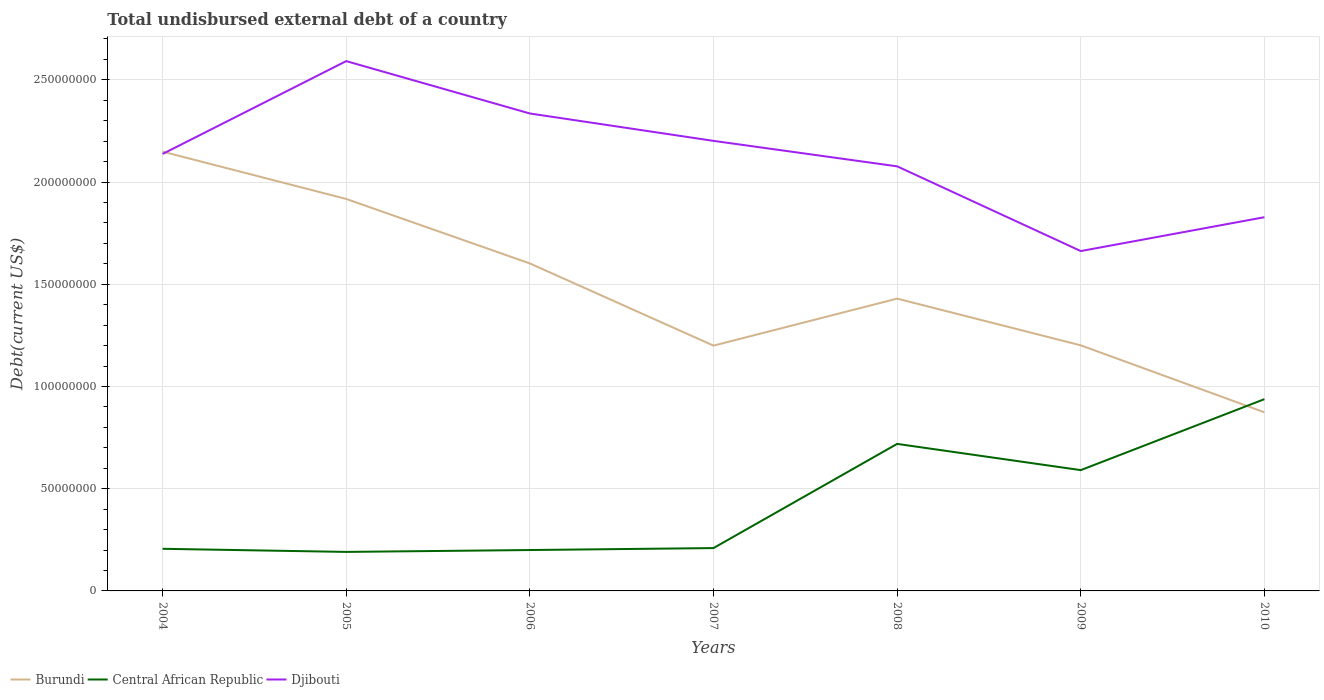How many different coloured lines are there?
Your response must be concise. 3. Is the number of lines equal to the number of legend labels?
Offer a terse response. Yes. Across all years, what is the maximum total undisbursed external debt in Djibouti?
Keep it short and to the point. 1.66e+08. In which year was the total undisbursed external debt in Djibouti maximum?
Give a very brief answer. 2009. What is the total total undisbursed external debt in Djibouti in the graph?
Provide a succinct answer. 2.56e+07. What is the difference between the highest and the second highest total undisbursed external debt in Burundi?
Your answer should be compact. 1.28e+08. What is the difference between the highest and the lowest total undisbursed external debt in Burundi?
Provide a succinct answer. 3. Is the total undisbursed external debt in Central African Republic strictly greater than the total undisbursed external debt in Burundi over the years?
Your answer should be very brief. No. What is the difference between two consecutive major ticks on the Y-axis?
Provide a succinct answer. 5.00e+07. Does the graph contain grids?
Provide a succinct answer. Yes. Where does the legend appear in the graph?
Provide a succinct answer. Bottom left. What is the title of the graph?
Give a very brief answer. Total undisbursed external debt of a country. Does "Philippines" appear as one of the legend labels in the graph?
Keep it short and to the point. No. What is the label or title of the Y-axis?
Give a very brief answer. Debt(current US$). What is the Debt(current US$) of Burundi in 2004?
Keep it short and to the point. 2.15e+08. What is the Debt(current US$) in Central African Republic in 2004?
Your answer should be very brief. 2.06e+07. What is the Debt(current US$) of Djibouti in 2004?
Provide a succinct answer. 2.14e+08. What is the Debt(current US$) in Burundi in 2005?
Your answer should be compact. 1.92e+08. What is the Debt(current US$) in Central African Republic in 2005?
Give a very brief answer. 1.91e+07. What is the Debt(current US$) of Djibouti in 2005?
Provide a succinct answer. 2.59e+08. What is the Debt(current US$) of Burundi in 2006?
Offer a terse response. 1.60e+08. What is the Debt(current US$) of Central African Republic in 2006?
Keep it short and to the point. 2.00e+07. What is the Debt(current US$) in Djibouti in 2006?
Keep it short and to the point. 2.34e+08. What is the Debt(current US$) of Burundi in 2007?
Your answer should be compact. 1.20e+08. What is the Debt(current US$) in Central African Republic in 2007?
Your answer should be compact. 2.10e+07. What is the Debt(current US$) in Djibouti in 2007?
Provide a short and direct response. 2.20e+08. What is the Debt(current US$) in Burundi in 2008?
Ensure brevity in your answer.  1.43e+08. What is the Debt(current US$) of Central African Republic in 2008?
Offer a very short reply. 7.19e+07. What is the Debt(current US$) in Djibouti in 2008?
Provide a succinct answer. 2.08e+08. What is the Debt(current US$) in Burundi in 2009?
Offer a terse response. 1.20e+08. What is the Debt(current US$) in Central African Republic in 2009?
Your response must be concise. 5.91e+07. What is the Debt(current US$) of Djibouti in 2009?
Make the answer very short. 1.66e+08. What is the Debt(current US$) in Burundi in 2010?
Give a very brief answer. 8.74e+07. What is the Debt(current US$) in Central African Republic in 2010?
Your answer should be compact. 9.38e+07. What is the Debt(current US$) of Djibouti in 2010?
Offer a terse response. 1.83e+08. Across all years, what is the maximum Debt(current US$) in Burundi?
Provide a short and direct response. 2.15e+08. Across all years, what is the maximum Debt(current US$) in Central African Republic?
Ensure brevity in your answer.  9.38e+07. Across all years, what is the maximum Debt(current US$) of Djibouti?
Provide a short and direct response. 2.59e+08. Across all years, what is the minimum Debt(current US$) of Burundi?
Ensure brevity in your answer.  8.74e+07. Across all years, what is the minimum Debt(current US$) in Central African Republic?
Provide a short and direct response. 1.91e+07. Across all years, what is the minimum Debt(current US$) of Djibouti?
Your answer should be compact. 1.66e+08. What is the total Debt(current US$) of Burundi in the graph?
Your answer should be very brief. 1.04e+09. What is the total Debt(current US$) of Central African Republic in the graph?
Ensure brevity in your answer.  3.05e+08. What is the total Debt(current US$) of Djibouti in the graph?
Offer a terse response. 1.48e+09. What is the difference between the Debt(current US$) in Burundi in 2004 and that in 2005?
Keep it short and to the point. 2.31e+07. What is the difference between the Debt(current US$) of Central African Republic in 2004 and that in 2005?
Ensure brevity in your answer.  1.52e+06. What is the difference between the Debt(current US$) in Djibouti in 2004 and that in 2005?
Your response must be concise. -4.54e+07. What is the difference between the Debt(current US$) in Burundi in 2004 and that in 2006?
Give a very brief answer. 5.47e+07. What is the difference between the Debt(current US$) of Central African Republic in 2004 and that in 2006?
Your response must be concise. 6.01e+05. What is the difference between the Debt(current US$) of Djibouti in 2004 and that in 2006?
Make the answer very short. -1.98e+07. What is the difference between the Debt(current US$) in Burundi in 2004 and that in 2007?
Your answer should be very brief. 9.49e+07. What is the difference between the Debt(current US$) in Central African Republic in 2004 and that in 2007?
Make the answer very short. -3.56e+05. What is the difference between the Debt(current US$) of Djibouti in 2004 and that in 2007?
Give a very brief answer. -6.40e+06. What is the difference between the Debt(current US$) of Burundi in 2004 and that in 2008?
Make the answer very short. 7.19e+07. What is the difference between the Debt(current US$) of Central African Republic in 2004 and that in 2008?
Give a very brief answer. -5.13e+07. What is the difference between the Debt(current US$) of Djibouti in 2004 and that in 2008?
Offer a very short reply. 6.05e+06. What is the difference between the Debt(current US$) of Burundi in 2004 and that in 2009?
Give a very brief answer. 9.48e+07. What is the difference between the Debt(current US$) of Central African Republic in 2004 and that in 2009?
Keep it short and to the point. -3.85e+07. What is the difference between the Debt(current US$) in Djibouti in 2004 and that in 2009?
Make the answer very short. 4.75e+07. What is the difference between the Debt(current US$) in Burundi in 2004 and that in 2010?
Provide a succinct answer. 1.28e+08. What is the difference between the Debt(current US$) in Central African Republic in 2004 and that in 2010?
Your answer should be very brief. -7.32e+07. What is the difference between the Debt(current US$) of Djibouti in 2004 and that in 2010?
Offer a terse response. 3.09e+07. What is the difference between the Debt(current US$) in Burundi in 2005 and that in 2006?
Offer a very short reply. 3.15e+07. What is the difference between the Debt(current US$) in Central African Republic in 2005 and that in 2006?
Your answer should be very brief. -9.19e+05. What is the difference between the Debt(current US$) in Djibouti in 2005 and that in 2006?
Make the answer very short. 2.56e+07. What is the difference between the Debt(current US$) in Burundi in 2005 and that in 2007?
Provide a succinct answer. 7.18e+07. What is the difference between the Debt(current US$) of Central African Republic in 2005 and that in 2007?
Keep it short and to the point. -1.88e+06. What is the difference between the Debt(current US$) of Djibouti in 2005 and that in 2007?
Give a very brief answer. 3.90e+07. What is the difference between the Debt(current US$) in Burundi in 2005 and that in 2008?
Your answer should be very brief. 4.88e+07. What is the difference between the Debt(current US$) of Central African Republic in 2005 and that in 2008?
Your answer should be very brief. -5.28e+07. What is the difference between the Debt(current US$) of Djibouti in 2005 and that in 2008?
Offer a very short reply. 5.15e+07. What is the difference between the Debt(current US$) in Burundi in 2005 and that in 2009?
Provide a short and direct response. 7.16e+07. What is the difference between the Debt(current US$) in Central African Republic in 2005 and that in 2009?
Provide a succinct answer. -4.00e+07. What is the difference between the Debt(current US$) in Djibouti in 2005 and that in 2009?
Provide a short and direct response. 9.29e+07. What is the difference between the Debt(current US$) of Burundi in 2005 and that in 2010?
Keep it short and to the point. 1.04e+08. What is the difference between the Debt(current US$) of Central African Republic in 2005 and that in 2010?
Your answer should be very brief. -7.47e+07. What is the difference between the Debt(current US$) in Djibouti in 2005 and that in 2010?
Provide a short and direct response. 7.64e+07. What is the difference between the Debt(current US$) of Burundi in 2006 and that in 2007?
Provide a short and direct response. 4.02e+07. What is the difference between the Debt(current US$) of Central African Republic in 2006 and that in 2007?
Your answer should be compact. -9.57e+05. What is the difference between the Debt(current US$) of Djibouti in 2006 and that in 2007?
Your response must be concise. 1.34e+07. What is the difference between the Debt(current US$) of Burundi in 2006 and that in 2008?
Offer a terse response. 1.72e+07. What is the difference between the Debt(current US$) of Central African Republic in 2006 and that in 2008?
Keep it short and to the point. -5.19e+07. What is the difference between the Debt(current US$) of Djibouti in 2006 and that in 2008?
Provide a short and direct response. 2.58e+07. What is the difference between the Debt(current US$) in Burundi in 2006 and that in 2009?
Your answer should be compact. 4.01e+07. What is the difference between the Debt(current US$) in Central African Republic in 2006 and that in 2009?
Your response must be concise. -3.91e+07. What is the difference between the Debt(current US$) in Djibouti in 2006 and that in 2009?
Offer a very short reply. 6.73e+07. What is the difference between the Debt(current US$) of Burundi in 2006 and that in 2010?
Offer a very short reply. 7.28e+07. What is the difference between the Debt(current US$) of Central African Republic in 2006 and that in 2010?
Your answer should be very brief. -7.38e+07. What is the difference between the Debt(current US$) in Djibouti in 2006 and that in 2010?
Your answer should be very brief. 5.07e+07. What is the difference between the Debt(current US$) of Burundi in 2007 and that in 2008?
Make the answer very short. -2.30e+07. What is the difference between the Debt(current US$) of Central African Republic in 2007 and that in 2008?
Ensure brevity in your answer.  -5.10e+07. What is the difference between the Debt(current US$) in Djibouti in 2007 and that in 2008?
Your response must be concise. 1.25e+07. What is the difference between the Debt(current US$) in Burundi in 2007 and that in 2009?
Make the answer very short. -1.48e+05. What is the difference between the Debt(current US$) of Central African Republic in 2007 and that in 2009?
Give a very brief answer. -3.81e+07. What is the difference between the Debt(current US$) of Djibouti in 2007 and that in 2009?
Give a very brief answer. 5.39e+07. What is the difference between the Debt(current US$) of Burundi in 2007 and that in 2010?
Your response must be concise. 3.26e+07. What is the difference between the Debt(current US$) in Central African Republic in 2007 and that in 2010?
Provide a succinct answer. -7.28e+07. What is the difference between the Debt(current US$) in Djibouti in 2007 and that in 2010?
Provide a succinct answer. 3.73e+07. What is the difference between the Debt(current US$) in Burundi in 2008 and that in 2009?
Offer a terse response. 2.28e+07. What is the difference between the Debt(current US$) in Central African Republic in 2008 and that in 2009?
Your answer should be compact. 1.28e+07. What is the difference between the Debt(current US$) of Djibouti in 2008 and that in 2009?
Your answer should be compact. 4.14e+07. What is the difference between the Debt(current US$) of Burundi in 2008 and that in 2010?
Offer a terse response. 5.56e+07. What is the difference between the Debt(current US$) of Central African Republic in 2008 and that in 2010?
Provide a short and direct response. -2.19e+07. What is the difference between the Debt(current US$) of Djibouti in 2008 and that in 2010?
Give a very brief answer. 2.49e+07. What is the difference between the Debt(current US$) in Burundi in 2009 and that in 2010?
Your response must be concise. 3.27e+07. What is the difference between the Debt(current US$) in Central African Republic in 2009 and that in 2010?
Ensure brevity in your answer.  -3.47e+07. What is the difference between the Debt(current US$) of Djibouti in 2009 and that in 2010?
Offer a terse response. -1.66e+07. What is the difference between the Debt(current US$) in Burundi in 2004 and the Debt(current US$) in Central African Republic in 2005?
Keep it short and to the point. 1.96e+08. What is the difference between the Debt(current US$) of Burundi in 2004 and the Debt(current US$) of Djibouti in 2005?
Your response must be concise. -4.43e+07. What is the difference between the Debt(current US$) in Central African Republic in 2004 and the Debt(current US$) in Djibouti in 2005?
Your answer should be very brief. -2.39e+08. What is the difference between the Debt(current US$) of Burundi in 2004 and the Debt(current US$) of Central African Republic in 2006?
Provide a succinct answer. 1.95e+08. What is the difference between the Debt(current US$) in Burundi in 2004 and the Debt(current US$) in Djibouti in 2006?
Your answer should be compact. -1.87e+07. What is the difference between the Debt(current US$) of Central African Republic in 2004 and the Debt(current US$) of Djibouti in 2006?
Provide a short and direct response. -2.13e+08. What is the difference between the Debt(current US$) of Burundi in 2004 and the Debt(current US$) of Central African Republic in 2007?
Your answer should be compact. 1.94e+08. What is the difference between the Debt(current US$) in Burundi in 2004 and the Debt(current US$) in Djibouti in 2007?
Provide a succinct answer. -5.26e+06. What is the difference between the Debt(current US$) of Central African Republic in 2004 and the Debt(current US$) of Djibouti in 2007?
Ensure brevity in your answer.  -2.00e+08. What is the difference between the Debt(current US$) of Burundi in 2004 and the Debt(current US$) of Central African Republic in 2008?
Offer a very short reply. 1.43e+08. What is the difference between the Debt(current US$) in Burundi in 2004 and the Debt(current US$) in Djibouti in 2008?
Offer a terse response. 7.19e+06. What is the difference between the Debt(current US$) of Central African Republic in 2004 and the Debt(current US$) of Djibouti in 2008?
Make the answer very short. -1.87e+08. What is the difference between the Debt(current US$) in Burundi in 2004 and the Debt(current US$) in Central African Republic in 2009?
Ensure brevity in your answer.  1.56e+08. What is the difference between the Debt(current US$) of Burundi in 2004 and the Debt(current US$) of Djibouti in 2009?
Give a very brief answer. 4.86e+07. What is the difference between the Debt(current US$) in Central African Republic in 2004 and the Debt(current US$) in Djibouti in 2009?
Offer a very short reply. -1.46e+08. What is the difference between the Debt(current US$) in Burundi in 2004 and the Debt(current US$) in Central African Republic in 2010?
Make the answer very short. 1.21e+08. What is the difference between the Debt(current US$) of Burundi in 2004 and the Debt(current US$) of Djibouti in 2010?
Give a very brief answer. 3.21e+07. What is the difference between the Debt(current US$) in Central African Republic in 2004 and the Debt(current US$) in Djibouti in 2010?
Ensure brevity in your answer.  -1.62e+08. What is the difference between the Debt(current US$) in Burundi in 2005 and the Debt(current US$) in Central African Republic in 2006?
Make the answer very short. 1.72e+08. What is the difference between the Debt(current US$) of Burundi in 2005 and the Debt(current US$) of Djibouti in 2006?
Give a very brief answer. -4.18e+07. What is the difference between the Debt(current US$) in Central African Republic in 2005 and the Debt(current US$) in Djibouti in 2006?
Provide a succinct answer. -2.14e+08. What is the difference between the Debt(current US$) in Burundi in 2005 and the Debt(current US$) in Central African Republic in 2007?
Keep it short and to the point. 1.71e+08. What is the difference between the Debt(current US$) of Burundi in 2005 and the Debt(current US$) of Djibouti in 2007?
Provide a short and direct response. -2.84e+07. What is the difference between the Debt(current US$) in Central African Republic in 2005 and the Debt(current US$) in Djibouti in 2007?
Provide a succinct answer. -2.01e+08. What is the difference between the Debt(current US$) of Burundi in 2005 and the Debt(current US$) of Central African Republic in 2008?
Offer a terse response. 1.20e+08. What is the difference between the Debt(current US$) in Burundi in 2005 and the Debt(current US$) in Djibouti in 2008?
Offer a terse response. -1.60e+07. What is the difference between the Debt(current US$) in Central African Republic in 2005 and the Debt(current US$) in Djibouti in 2008?
Provide a short and direct response. -1.89e+08. What is the difference between the Debt(current US$) in Burundi in 2005 and the Debt(current US$) in Central African Republic in 2009?
Provide a short and direct response. 1.33e+08. What is the difference between the Debt(current US$) of Burundi in 2005 and the Debt(current US$) of Djibouti in 2009?
Provide a succinct answer. 2.55e+07. What is the difference between the Debt(current US$) of Central African Republic in 2005 and the Debt(current US$) of Djibouti in 2009?
Provide a short and direct response. -1.47e+08. What is the difference between the Debt(current US$) of Burundi in 2005 and the Debt(current US$) of Central African Republic in 2010?
Provide a succinct answer. 9.79e+07. What is the difference between the Debt(current US$) in Burundi in 2005 and the Debt(current US$) in Djibouti in 2010?
Give a very brief answer. 8.93e+06. What is the difference between the Debt(current US$) of Central African Republic in 2005 and the Debt(current US$) of Djibouti in 2010?
Give a very brief answer. -1.64e+08. What is the difference between the Debt(current US$) in Burundi in 2006 and the Debt(current US$) in Central African Republic in 2007?
Your response must be concise. 1.39e+08. What is the difference between the Debt(current US$) of Burundi in 2006 and the Debt(current US$) of Djibouti in 2007?
Give a very brief answer. -6.00e+07. What is the difference between the Debt(current US$) in Central African Republic in 2006 and the Debt(current US$) in Djibouti in 2007?
Ensure brevity in your answer.  -2.00e+08. What is the difference between the Debt(current US$) of Burundi in 2006 and the Debt(current US$) of Central African Republic in 2008?
Make the answer very short. 8.83e+07. What is the difference between the Debt(current US$) of Burundi in 2006 and the Debt(current US$) of Djibouti in 2008?
Offer a terse response. -4.75e+07. What is the difference between the Debt(current US$) of Central African Republic in 2006 and the Debt(current US$) of Djibouti in 2008?
Give a very brief answer. -1.88e+08. What is the difference between the Debt(current US$) in Burundi in 2006 and the Debt(current US$) in Central African Republic in 2009?
Your answer should be very brief. 1.01e+08. What is the difference between the Debt(current US$) in Burundi in 2006 and the Debt(current US$) in Djibouti in 2009?
Make the answer very short. -6.05e+06. What is the difference between the Debt(current US$) of Central African Republic in 2006 and the Debt(current US$) of Djibouti in 2009?
Keep it short and to the point. -1.46e+08. What is the difference between the Debt(current US$) of Burundi in 2006 and the Debt(current US$) of Central African Republic in 2010?
Your answer should be very brief. 6.64e+07. What is the difference between the Debt(current US$) of Burundi in 2006 and the Debt(current US$) of Djibouti in 2010?
Make the answer very short. -2.26e+07. What is the difference between the Debt(current US$) of Central African Republic in 2006 and the Debt(current US$) of Djibouti in 2010?
Your answer should be compact. -1.63e+08. What is the difference between the Debt(current US$) of Burundi in 2007 and the Debt(current US$) of Central African Republic in 2008?
Your answer should be compact. 4.81e+07. What is the difference between the Debt(current US$) of Burundi in 2007 and the Debt(current US$) of Djibouti in 2008?
Give a very brief answer. -8.77e+07. What is the difference between the Debt(current US$) of Central African Republic in 2007 and the Debt(current US$) of Djibouti in 2008?
Ensure brevity in your answer.  -1.87e+08. What is the difference between the Debt(current US$) in Burundi in 2007 and the Debt(current US$) in Central African Republic in 2009?
Provide a succinct answer. 6.09e+07. What is the difference between the Debt(current US$) of Burundi in 2007 and the Debt(current US$) of Djibouti in 2009?
Ensure brevity in your answer.  -4.63e+07. What is the difference between the Debt(current US$) of Central African Republic in 2007 and the Debt(current US$) of Djibouti in 2009?
Your response must be concise. -1.45e+08. What is the difference between the Debt(current US$) of Burundi in 2007 and the Debt(current US$) of Central African Republic in 2010?
Make the answer very short. 2.62e+07. What is the difference between the Debt(current US$) in Burundi in 2007 and the Debt(current US$) in Djibouti in 2010?
Your answer should be very brief. -6.28e+07. What is the difference between the Debt(current US$) in Central African Republic in 2007 and the Debt(current US$) in Djibouti in 2010?
Give a very brief answer. -1.62e+08. What is the difference between the Debt(current US$) in Burundi in 2008 and the Debt(current US$) in Central African Republic in 2009?
Your answer should be compact. 8.39e+07. What is the difference between the Debt(current US$) of Burundi in 2008 and the Debt(current US$) of Djibouti in 2009?
Offer a terse response. -2.33e+07. What is the difference between the Debt(current US$) in Central African Republic in 2008 and the Debt(current US$) in Djibouti in 2009?
Give a very brief answer. -9.43e+07. What is the difference between the Debt(current US$) in Burundi in 2008 and the Debt(current US$) in Central African Republic in 2010?
Give a very brief answer. 4.92e+07. What is the difference between the Debt(current US$) of Burundi in 2008 and the Debt(current US$) of Djibouti in 2010?
Provide a succinct answer. -3.98e+07. What is the difference between the Debt(current US$) of Central African Republic in 2008 and the Debt(current US$) of Djibouti in 2010?
Provide a succinct answer. -1.11e+08. What is the difference between the Debt(current US$) in Burundi in 2009 and the Debt(current US$) in Central African Republic in 2010?
Ensure brevity in your answer.  2.63e+07. What is the difference between the Debt(current US$) in Burundi in 2009 and the Debt(current US$) in Djibouti in 2010?
Ensure brevity in your answer.  -6.27e+07. What is the difference between the Debt(current US$) of Central African Republic in 2009 and the Debt(current US$) of Djibouti in 2010?
Your answer should be very brief. -1.24e+08. What is the average Debt(current US$) of Burundi per year?
Provide a succinct answer. 1.48e+08. What is the average Debt(current US$) in Central African Republic per year?
Give a very brief answer. 4.36e+07. What is the average Debt(current US$) of Djibouti per year?
Offer a terse response. 2.12e+08. In the year 2004, what is the difference between the Debt(current US$) of Burundi and Debt(current US$) of Central African Republic?
Provide a succinct answer. 1.94e+08. In the year 2004, what is the difference between the Debt(current US$) in Burundi and Debt(current US$) in Djibouti?
Give a very brief answer. 1.14e+06. In the year 2004, what is the difference between the Debt(current US$) of Central African Republic and Debt(current US$) of Djibouti?
Ensure brevity in your answer.  -1.93e+08. In the year 2005, what is the difference between the Debt(current US$) in Burundi and Debt(current US$) in Central African Republic?
Your answer should be compact. 1.73e+08. In the year 2005, what is the difference between the Debt(current US$) of Burundi and Debt(current US$) of Djibouti?
Provide a short and direct response. -6.74e+07. In the year 2005, what is the difference between the Debt(current US$) in Central African Republic and Debt(current US$) in Djibouti?
Your answer should be very brief. -2.40e+08. In the year 2006, what is the difference between the Debt(current US$) in Burundi and Debt(current US$) in Central African Republic?
Offer a terse response. 1.40e+08. In the year 2006, what is the difference between the Debt(current US$) in Burundi and Debt(current US$) in Djibouti?
Your response must be concise. -7.33e+07. In the year 2006, what is the difference between the Debt(current US$) of Central African Republic and Debt(current US$) of Djibouti?
Offer a very short reply. -2.14e+08. In the year 2007, what is the difference between the Debt(current US$) in Burundi and Debt(current US$) in Central African Republic?
Keep it short and to the point. 9.90e+07. In the year 2007, what is the difference between the Debt(current US$) of Burundi and Debt(current US$) of Djibouti?
Ensure brevity in your answer.  -1.00e+08. In the year 2007, what is the difference between the Debt(current US$) in Central African Republic and Debt(current US$) in Djibouti?
Give a very brief answer. -1.99e+08. In the year 2008, what is the difference between the Debt(current US$) in Burundi and Debt(current US$) in Central African Republic?
Offer a terse response. 7.11e+07. In the year 2008, what is the difference between the Debt(current US$) of Burundi and Debt(current US$) of Djibouti?
Your answer should be compact. -6.47e+07. In the year 2008, what is the difference between the Debt(current US$) in Central African Republic and Debt(current US$) in Djibouti?
Offer a terse response. -1.36e+08. In the year 2009, what is the difference between the Debt(current US$) in Burundi and Debt(current US$) in Central African Republic?
Offer a very short reply. 6.10e+07. In the year 2009, what is the difference between the Debt(current US$) of Burundi and Debt(current US$) of Djibouti?
Provide a short and direct response. -4.61e+07. In the year 2009, what is the difference between the Debt(current US$) in Central African Republic and Debt(current US$) in Djibouti?
Give a very brief answer. -1.07e+08. In the year 2010, what is the difference between the Debt(current US$) in Burundi and Debt(current US$) in Central African Republic?
Ensure brevity in your answer.  -6.42e+06. In the year 2010, what is the difference between the Debt(current US$) in Burundi and Debt(current US$) in Djibouti?
Offer a very short reply. -9.54e+07. In the year 2010, what is the difference between the Debt(current US$) of Central African Republic and Debt(current US$) of Djibouti?
Make the answer very short. -8.90e+07. What is the ratio of the Debt(current US$) in Burundi in 2004 to that in 2005?
Provide a succinct answer. 1.12. What is the ratio of the Debt(current US$) in Central African Republic in 2004 to that in 2005?
Provide a succinct answer. 1.08. What is the ratio of the Debt(current US$) of Djibouti in 2004 to that in 2005?
Offer a very short reply. 0.82. What is the ratio of the Debt(current US$) of Burundi in 2004 to that in 2006?
Provide a succinct answer. 1.34. What is the ratio of the Debt(current US$) of Central African Republic in 2004 to that in 2006?
Offer a terse response. 1.03. What is the ratio of the Debt(current US$) of Djibouti in 2004 to that in 2006?
Offer a very short reply. 0.92. What is the ratio of the Debt(current US$) in Burundi in 2004 to that in 2007?
Give a very brief answer. 1.79. What is the ratio of the Debt(current US$) in Djibouti in 2004 to that in 2007?
Your answer should be very brief. 0.97. What is the ratio of the Debt(current US$) of Burundi in 2004 to that in 2008?
Give a very brief answer. 1.5. What is the ratio of the Debt(current US$) in Central African Republic in 2004 to that in 2008?
Ensure brevity in your answer.  0.29. What is the ratio of the Debt(current US$) of Djibouti in 2004 to that in 2008?
Your answer should be very brief. 1.03. What is the ratio of the Debt(current US$) in Burundi in 2004 to that in 2009?
Offer a very short reply. 1.79. What is the ratio of the Debt(current US$) of Central African Republic in 2004 to that in 2009?
Give a very brief answer. 0.35. What is the ratio of the Debt(current US$) in Burundi in 2004 to that in 2010?
Your answer should be compact. 2.46. What is the ratio of the Debt(current US$) of Central African Republic in 2004 to that in 2010?
Offer a terse response. 0.22. What is the ratio of the Debt(current US$) in Djibouti in 2004 to that in 2010?
Give a very brief answer. 1.17. What is the ratio of the Debt(current US$) in Burundi in 2005 to that in 2006?
Keep it short and to the point. 1.2. What is the ratio of the Debt(current US$) in Central African Republic in 2005 to that in 2006?
Your answer should be very brief. 0.95. What is the ratio of the Debt(current US$) of Djibouti in 2005 to that in 2006?
Your answer should be very brief. 1.11. What is the ratio of the Debt(current US$) in Burundi in 2005 to that in 2007?
Make the answer very short. 1.6. What is the ratio of the Debt(current US$) of Central African Republic in 2005 to that in 2007?
Your response must be concise. 0.91. What is the ratio of the Debt(current US$) in Djibouti in 2005 to that in 2007?
Your answer should be compact. 1.18. What is the ratio of the Debt(current US$) of Burundi in 2005 to that in 2008?
Your response must be concise. 1.34. What is the ratio of the Debt(current US$) of Central African Republic in 2005 to that in 2008?
Provide a succinct answer. 0.27. What is the ratio of the Debt(current US$) of Djibouti in 2005 to that in 2008?
Offer a terse response. 1.25. What is the ratio of the Debt(current US$) in Burundi in 2005 to that in 2009?
Your answer should be compact. 1.6. What is the ratio of the Debt(current US$) of Central African Republic in 2005 to that in 2009?
Offer a very short reply. 0.32. What is the ratio of the Debt(current US$) of Djibouti in 2005 to that in 2009?
Offer a terse response. 1.56. What is the ratio of the Debt(current US$) in Burundi in 2005 to that in 2010?
Your answer should be very brief. 2.19. What is the ratio of the Debt(current US$) in Central African Republic in 2005 to that in 2010?
Offer a very short reply. 0.2. What is the ratio of the Debt(current US$) in Djibouti in 2005 to that in 2010?
Keep it short and to the point. 1.42. What is the ratio of the Debt(current US$) of Burundi in 2006 to that in 2007?
Your response must be concise. 1.34. What is the ratio of the Debt(current US$) of Central African Republic in 2006 to that in 2007?
Keep it short and to the point. 0.95. What is the ratio of the Debt(current US$) in Djibouti in 2006 to that in 2007?
Your answer should be very brief. 1.06. What is the ratio of the Debt(current US$) of Burundi in 2006 to that in 2008?
Your response must be concise. 1.12. What is the ratio of the Debt(current US$) of Central African Republic in 2006 to that in 2008?
Give a very brief answer. 0.28. What is the ratio of the Debt(current US$) of Djibouti in 2006 to that in 2008?
Ensure brevity in your answer.  1.12. What is the ratio of the Debt(current US$) of Burundi in 2006 to that in 2009?
Your answer should be very brief. 1.33. What is the ratio of the Debt(current US$) in Central African Republic in 2006 to that in 2009?
Keep it short and to the point. 0.34. What is the ratio of the Debt(current US$) of Djibouti in 2006 to that in 2009?
Your answer should be very brief. 1.4. What is the ratio of the Debt(current US$) of Burundi in 2006 to that in 2010?
Your answer should be very brief. 1.83. What is the ratio of the Debt(current US$) in Central African Republic in 2006 to that in 2010?
Your answer should be very brief. 0.21. What is the ratio of the Debt(current US$) in Djibouti in 2006 to that in 2010?
Your answer should be very brief. 1.28. What is the ratio of the Debt(current US$) in Burundi in 2007 to that in 2008?
Your answer should be compact. 0.84. What is the ratio of the Debt(current US$) of Central African Republic in 2007 to that in 2008?
Your response must be concise. 0.29. What is the ratio of the Debt(current US$) in Djibouti in 2007 to that in 2008?
Make the answer very short. 1.06. What is the ratio of the Debt(current US$) in Central African Republic in 2007 to that in 2009?
Your answer should be compact. 0.35. What is the ratio of the Debt(current US$) in Djibouti in 2007 to that in 2009?
Offer a very short reply. 1.32. What is the ratio of the Debt(current US$) of Burundi in 2007 to that in 2010?
Your answer should be very brief. 1.37. What is the ratio of the Debt(current US$) of Central African Republic in 2007 to that in 2010?
Provide a short and direct response. 0.22. What is the ratio of the Debt(current US$) of Djibouti in 2007 to that in 2010?
Keep it short and to the point. 1.2. What is the ratio of the Debt(current US$) in Burundi in 2008 to that in 2009?
Make the answer very short. 1.19. What is the ratio of the Debt(current US$) in Central African Republic in 2008 to that in 2009?
Your response must be concise. 1.22. What is the ratio of the Debt(current US$) in Djibouti in 2008 to that in 2009?
Provide a succinct answer. 1.25. What is the ratio of the Debt(current US$) of Burundi in 2008 to that in 2010?
Provide a short and direct response. 1.64. What is the ratio of the Debt(current US$) in Central African Republic in 2008 to that in 2010?
Make the answer very short. 0.77. What is the ratio of the Debt(current US$) of Djibouti in 2008 to that in 2010?
Offer a very short reply. 1.14. What is the ratio of the Debt(current US$) in Burundi in 2009 to that in 2010?
Your answer should be compact. 1.37. What is the ratio of the Debt(current US$) in Central African Republic in 2009 to that in 2010?
Keep it short and to the point. 0.63. What is the ratio of the Debt(current US$) of Djibouti in 2009 to that in 2010?
Provide a short and direct response. 0.91. What is the difference between the highest and the second highest Debt(current US$) of Burundi?
Your answer should be very brief. 2.31e+07. What is the difference between the highest and the second highest Debt(current US$) of Central African Republic?
Provide a succinct answer. 2.19e+07. What is the difference between the highest and the second highest Debt(current US$) of Djibouti?
Provide a short and direct response. 2.56e+07. What is the difference between the highest and the lowest Debt(current US$) of Burundi?
Your response must be concise. 1.28e+08. What is the difference between the highest and the lowest Debt(current US$) in Central African Republic?
Offer a terse response. 7.47e+07. What is the difference between the highest and the lowest Debt(current US$) of Djibouti?
Your response must be concise. 9.29e+07. 